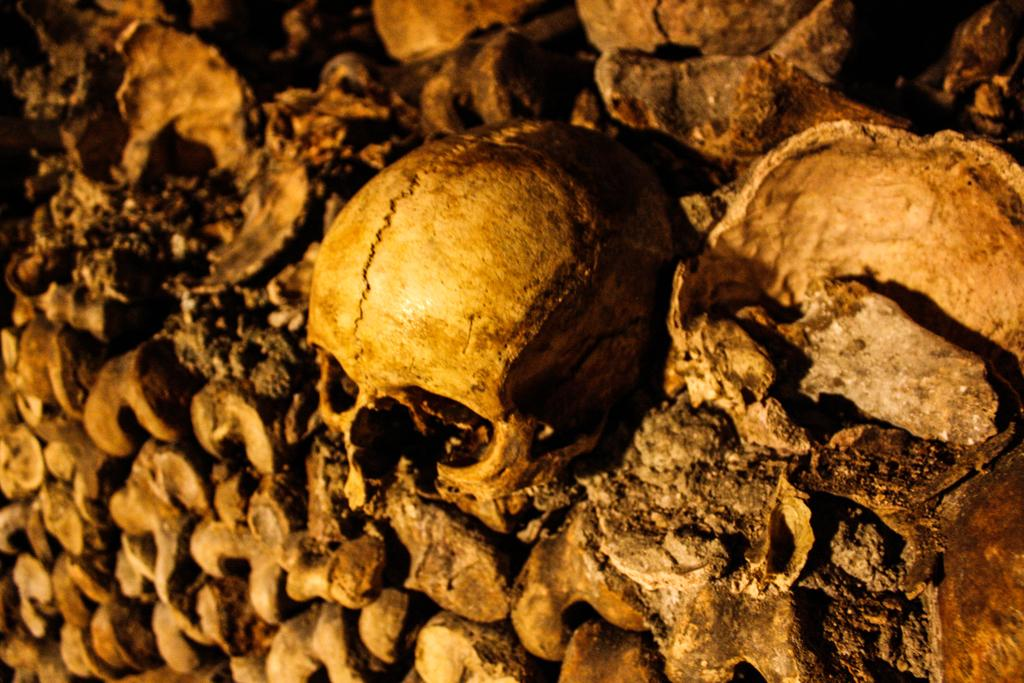What type of objects can be seen in the image? There are skulls and bones in the image. Can you describe the appearance of the skulls? The skulls appear to be human or animal skulls, but it is difficult to determine the exact species from the image. What other objects are present in the image besides the skulls and bones? The provided facts do not mention any other objects in the image. What type of ticket is required to enter the school depicted in the image? There is no school depicted in the image, and therefore no ticket is required for entry. What position does the person holding the skull have in the image? There is no person holding the skull in the image, as the provided facts only mention the presence of skulls and bones. 